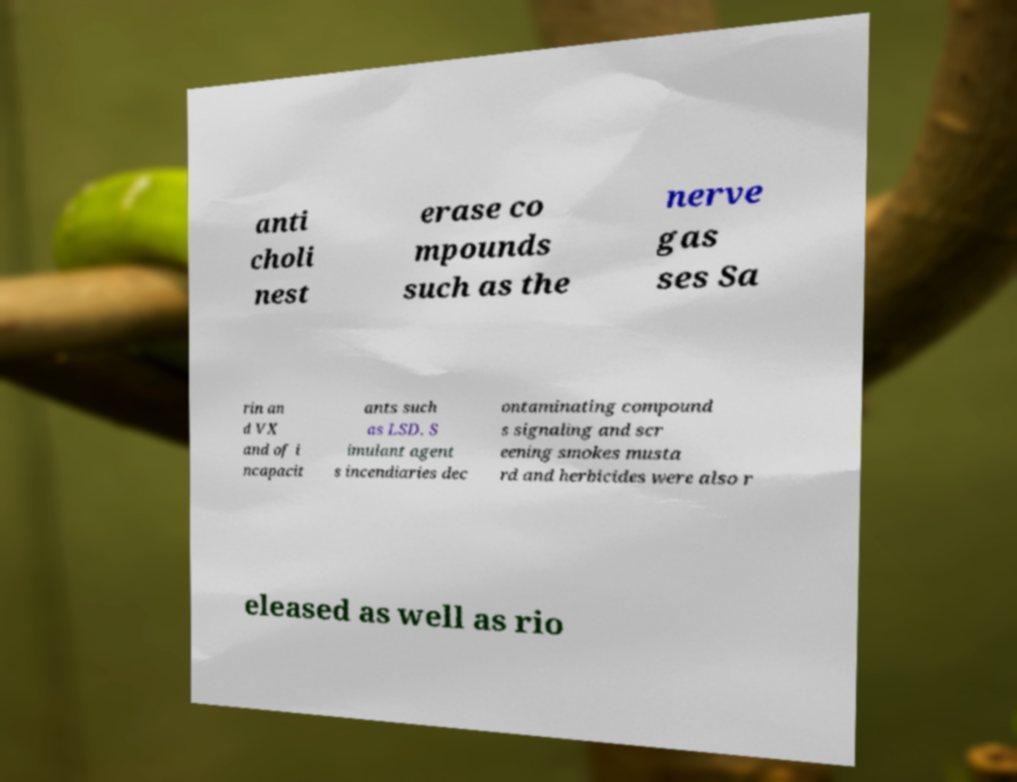Can you read and provide the text displayed in the image?This photo seems to have some interesting text. Can you extract and type it out for me? anti choli nest erase co mpounds such as the nerve gas ses Sa rin an d VX and of i ncapacit ants such as LSD. S imulant agent s incendiaries dec ontaminating compound s signaling and scr eening smokes musta rd and herbicides were also r eleased as well as rio 